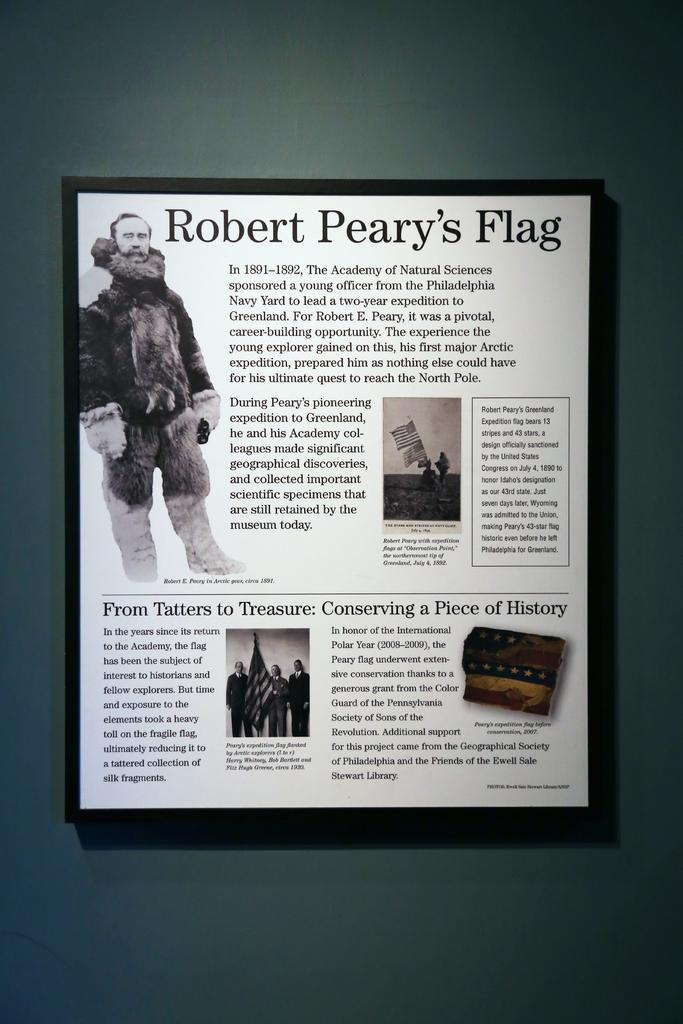What is hanging on the wall in the image? There is a portrait on a wall in the image. What is depicted within the portrait? The portrait contains pictures. Are there any words or letters in the portrait? Yes, there is text present in the portrait. What type of plantation is shown in the portrait? There is no plantation depicted in the portrait; it contains pictures and text. 